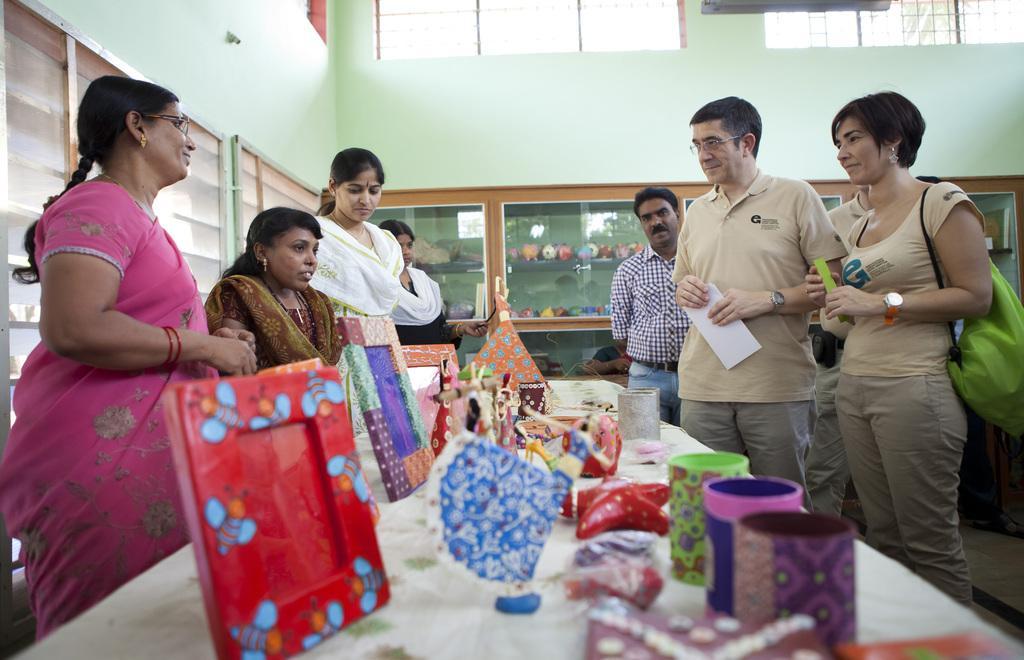In one or two sentences, can you explain what this image depicts? In this picture we can see few people, in front of them we can see few cups, frames and other things on the table, on the right side of the image we can see a woman, she is carrying a bag, in the background we can see few toys in the racks. 